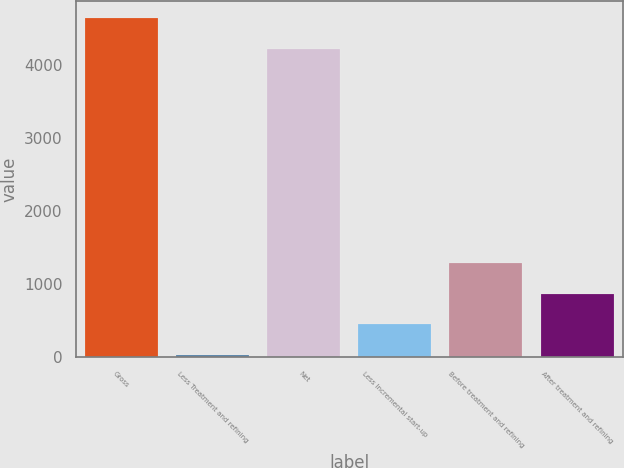<chart> <loc_0><loc_0><loc_500><loc_500><bar_chart><fcel>Gross<fcel>Less Treatment and refining<fcel>Net<fcel>Less Incremental start-up<fcel>Before treatment and refining<fcel>After treatment and refining<nl><fcel>4632.1<fcel>30<fcel>4211<fcel>451.1<fcel>1293.3<fcel>872.2<nl></chart> 